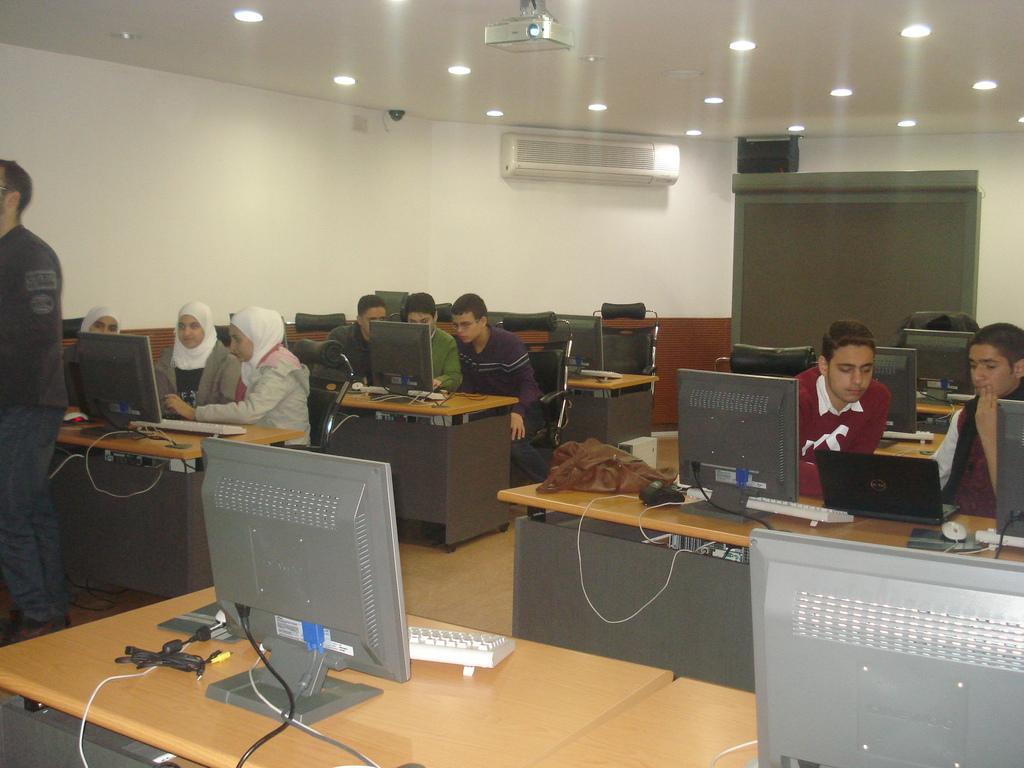In one or two sentences, can you explain what this image depicts? In this picture there is a light on the roof. There is an air conditioner on the wall. On to the left,there is a man who is standing and is wearing a grey shirt. There is a computer and a keyboard on the table. There are three women sitting on the chair. In the middle there are three men sitting on chair and are looking into the computer. On to the right, there are two men who are also sitting on the chair and is looking into the laptop. There is a bag on the table and a wire on the table. 